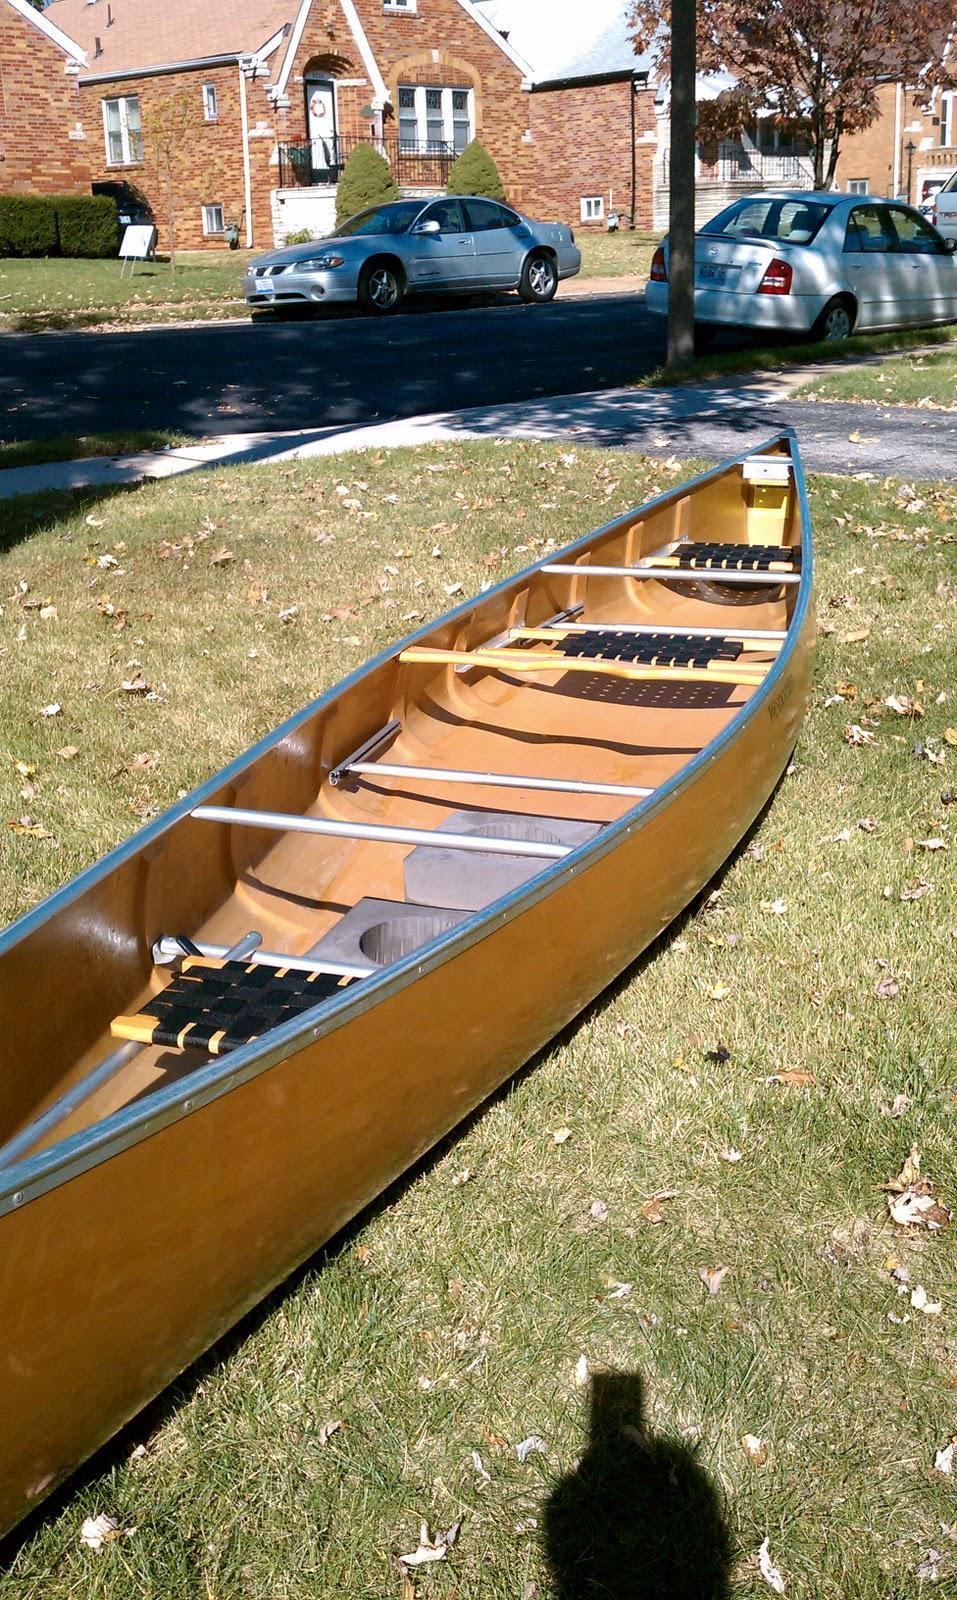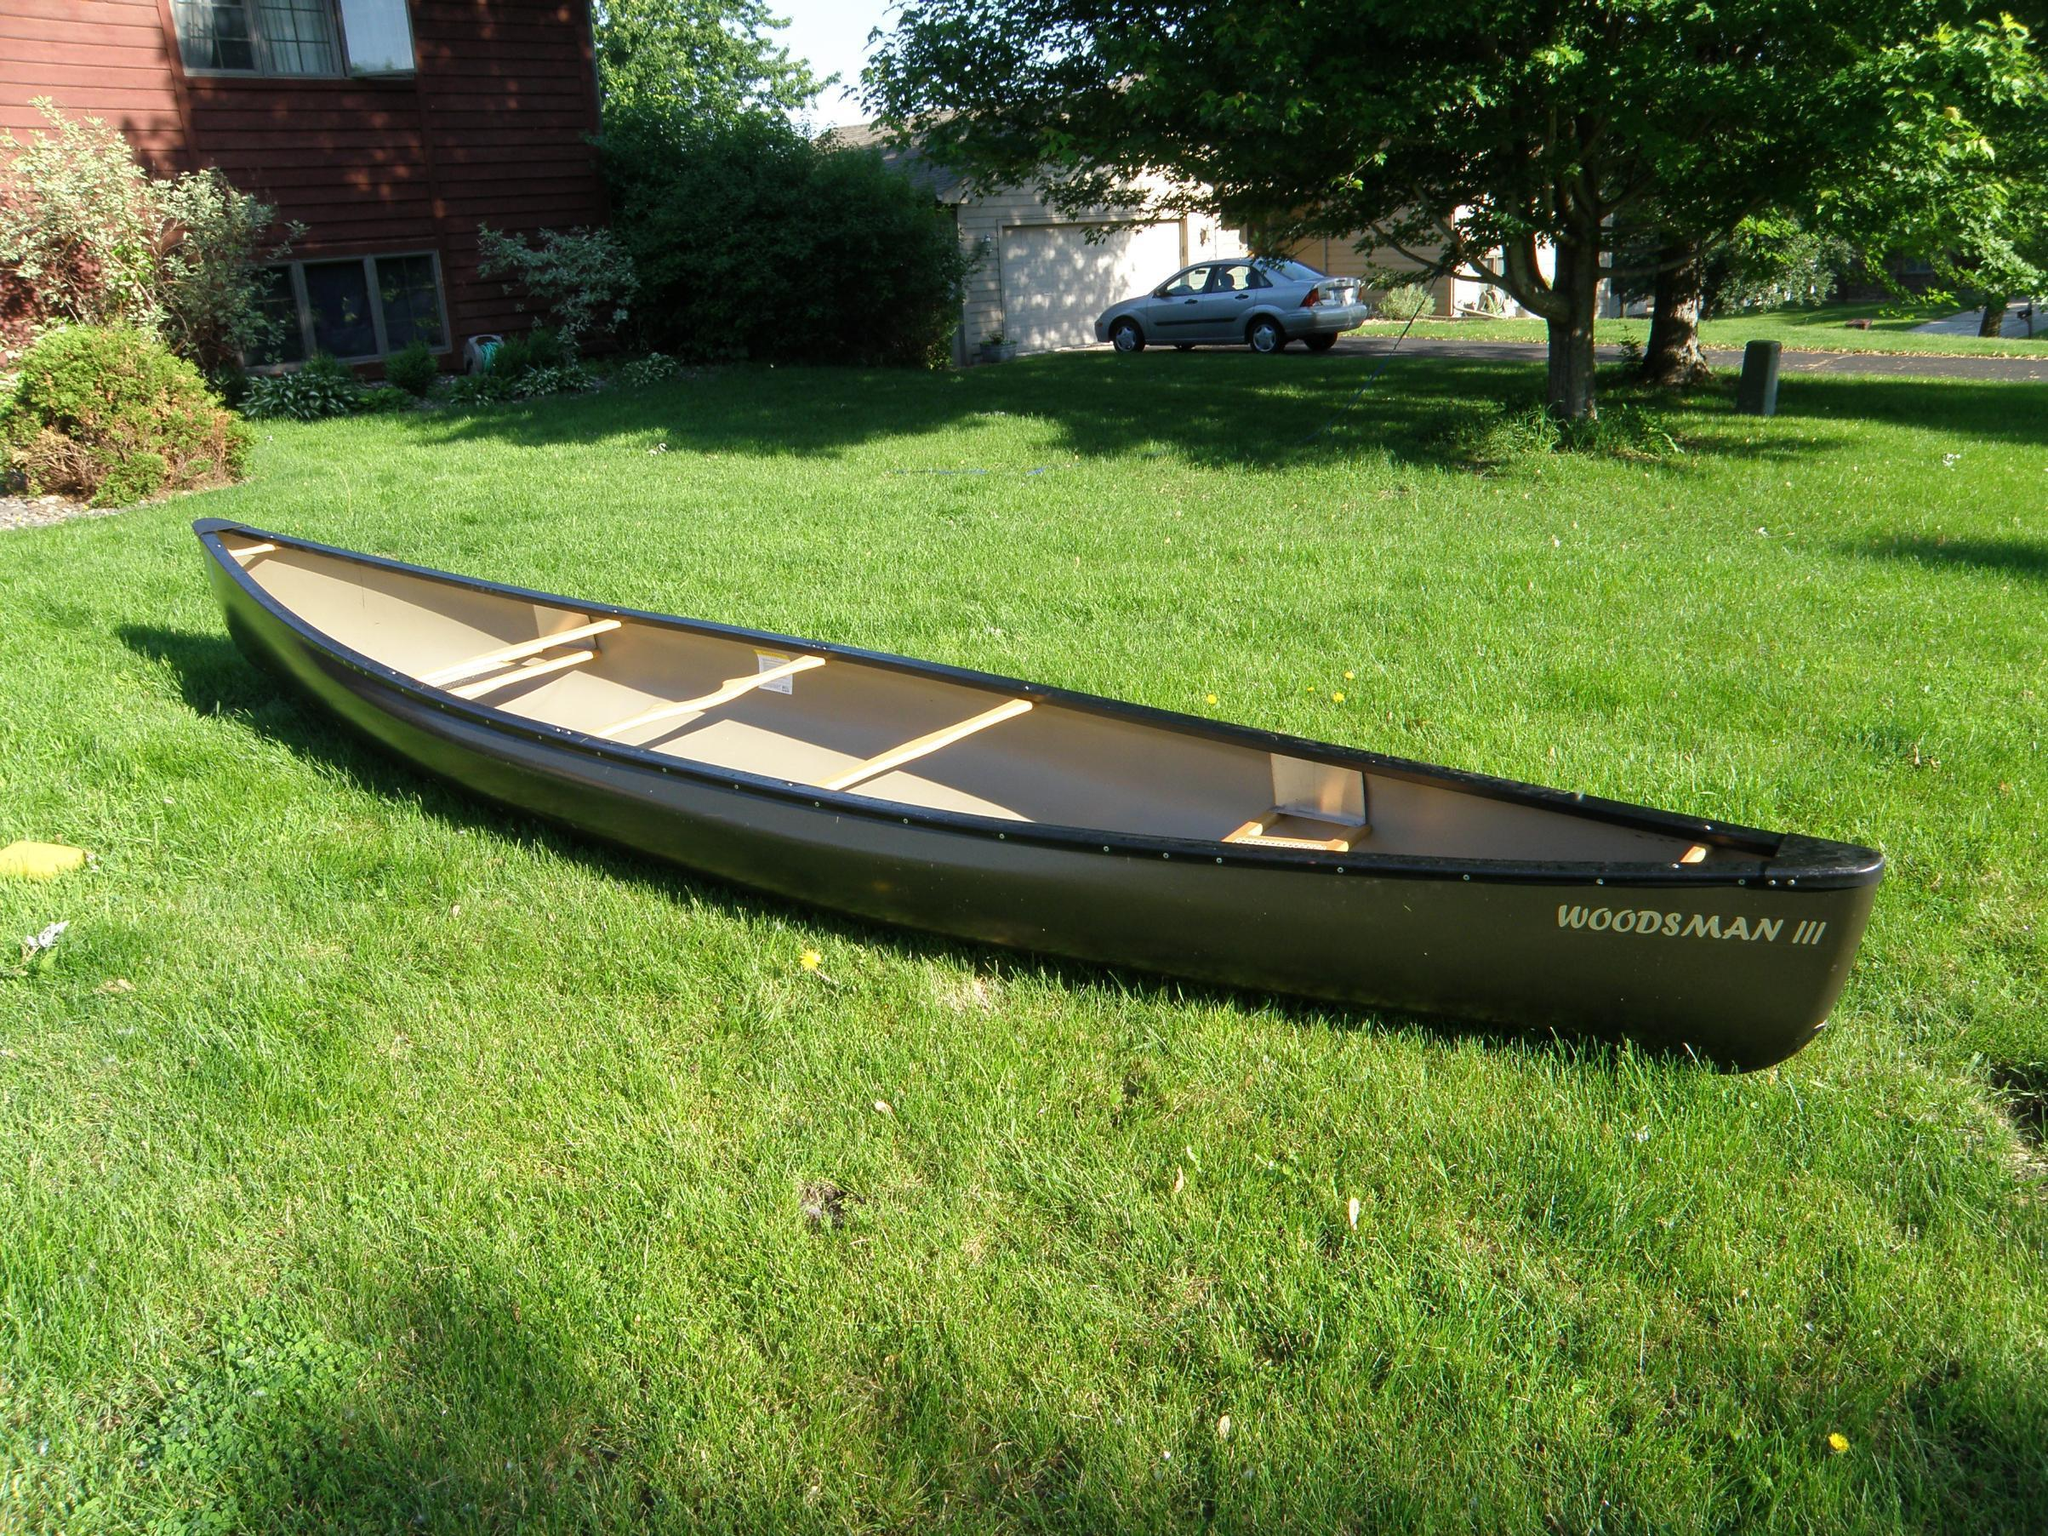The first image is the image on the left, the second image is the image on the right. For the images displayed, is the sentence "The left and right image contains the same number of boat on land." factually correct? Answer yes or no. Yes. The first image is the image on the left, the second image is the image on the right. Assess this claim about the two images: "Two canoes are sitting on the ground.". Correct or not? Answer yes or no. Yes. 